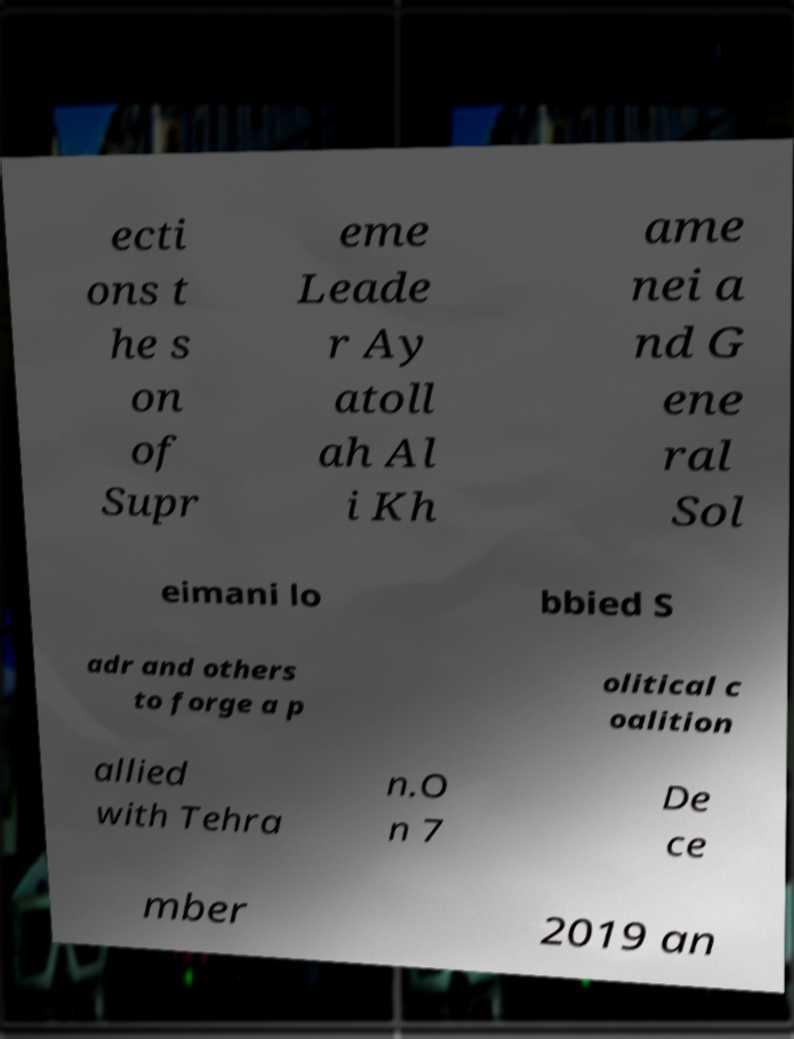Can you read and provide the text displayed in the image?This photo seems to have some interesting text. Can you extract and type it out for me? ecti ons t he s on of Supr eme Leade r Ay atoll ah Al i Kh ame nei a nd G ene ral Sol eimani lo bbied S adr and others to forge a p olitical c oalition allied with Tehra n.O n 7 De ce mber 2019 an 